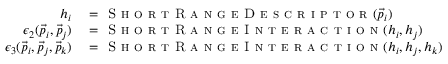Convert formula to latex. <formula><loc_0><loc_0><loc_500><loc_500>\begin{array} { r l } { h _ { i } } & = S h o r t R a n g e D e s c r i p t o r ( \vec { p } _ { i } ) } \\ { \epsilon _ { 2 } ( \vec { p } _ { i } , \vec { p } _ { j } ) } & = S h o r t R a n g e I n t e r a c t i o n ( h _ { i } , h _ { j } ) } \\ { \epsilon _ { 3 } ( \vec { p } _ { i } , \vec { p } _ { j } , \vec { p } _ { k } ) } & = S h o r t R a n g e I n t e r a c t i o n ( h _ { i } , h _ { j } , h _ { k } ) } \end{array}</formula> 